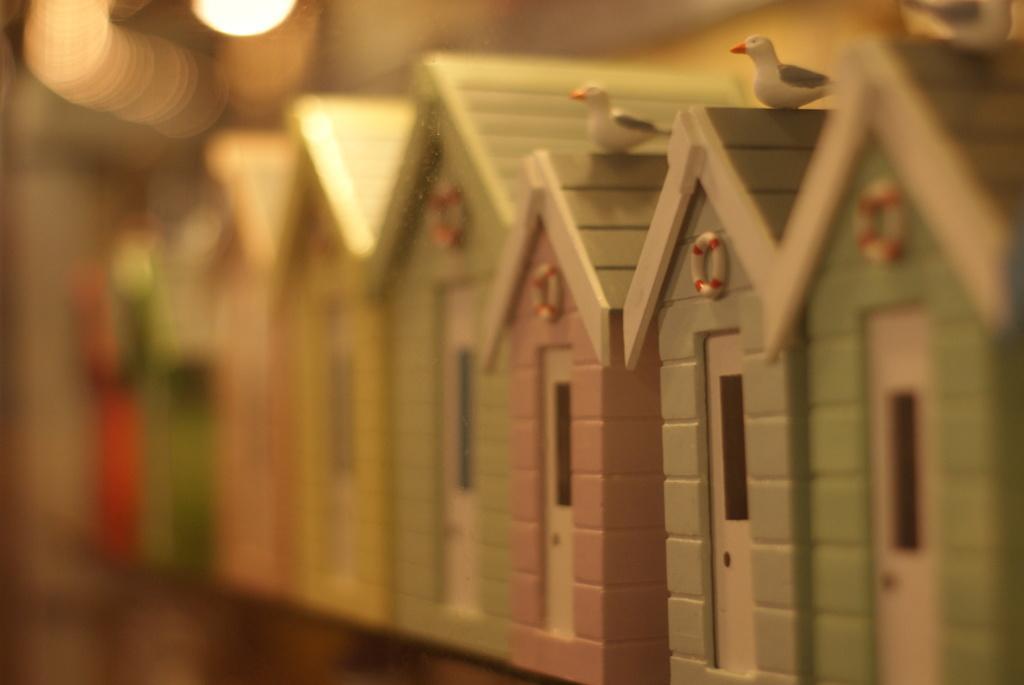How would you summarize this image in a sentence or two? In this picture I can see toy wooden shelters. 